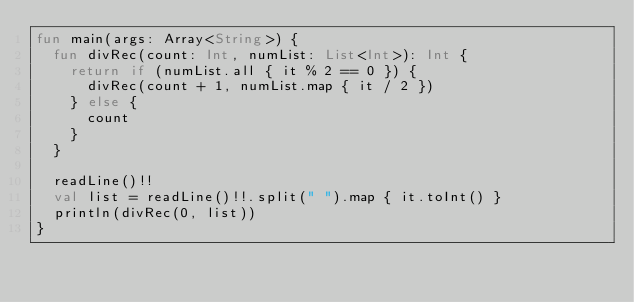<code> <loc_0><loc_0><loc_500><loc_500><_Kotlin_>fun main(args: Array<String>) {
  fun divRec(count: Int, numList: List<Int>): Int {
    return if (numList.all { it % 2 == 0 }) {
      divRec(count + 1, numList.map { it / 2 })
    } else {
      count
    }
  }

  readLine()!!
  val list = readLine()!!.split(" ").map { it.toInt() }
  println(divRec(0, list))
}</code> 